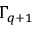Convert formula to latex. <formula><loc_0><loc_0><loc_500><loc_500>\Gamma _ { q + 1 }</formula> 